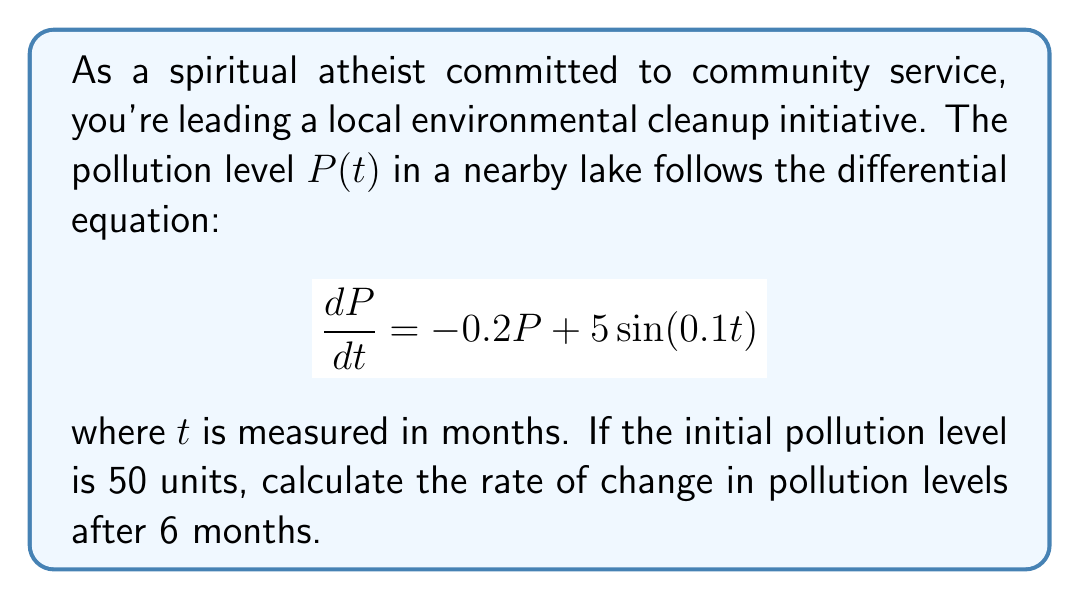Could you help me with this problem? 1) First, we need to solve the differential equation to find $P(t)$:
   The general solution is of the form: $P(t) = P_h + P_p$
   where $P_h$ is the homogeneous solution and $P_p$ is the particular solution.

2) Homogeneous solution:
   $\frac{dP_h}{dt} = -0.2P_h$
   $P_h = Ce^{-0.2t}$, where $C$ is a constant.

3) Particular solution:
   Try $P_p = A\cos(0.1t) + B\sin(0.1t)$
   Substituting into the original equation:
   $-0.1A\sin(0.1t) + 0.1B\cos(0.1t) = -0.2(A\cos(0.1t) + B\sin(0.1t)) + 5\sin(0.1t)$
   Equating coefficients:
   $-0.1A = -0.2B$
   $0.1B = -0.2A + 5$
   Solving these equations: $A = -4.9$ and $B = 24.5$

4) General solution:
   $P(t) = Ce^{-0.2t} - 4.9\cos(0.1t) + 24.5\sin(0.1t)$

5) Using the initial condition $P(0) = 50$:
   $50 = C - 4.9$
   $C = 54.9$

6) Therefore, the particular solution is:
   $P(t) = 54.9e^{-0.2t} - 4.9\cos(0.1t) + 24.5\sin(0.1t)$

7) To find the rate of change at $t=6$, we differentiate $P(t)$:
   $\frac{dP}{dt} = -11.98e^{-0.2t} + 0.49\sin(0.1t) + 2.45\cos(0.1t)$

8) Evaluating at $t=6$:
   $\frac{dP}{dt}(6) = -11.98e^{-1.2} + 0.49\sin(0.6) + 2.45\cos(0.6)$
   $= -3.64 + 0.29 + 1.72 = -1.63$
Answer: $-1.63$ units/month 